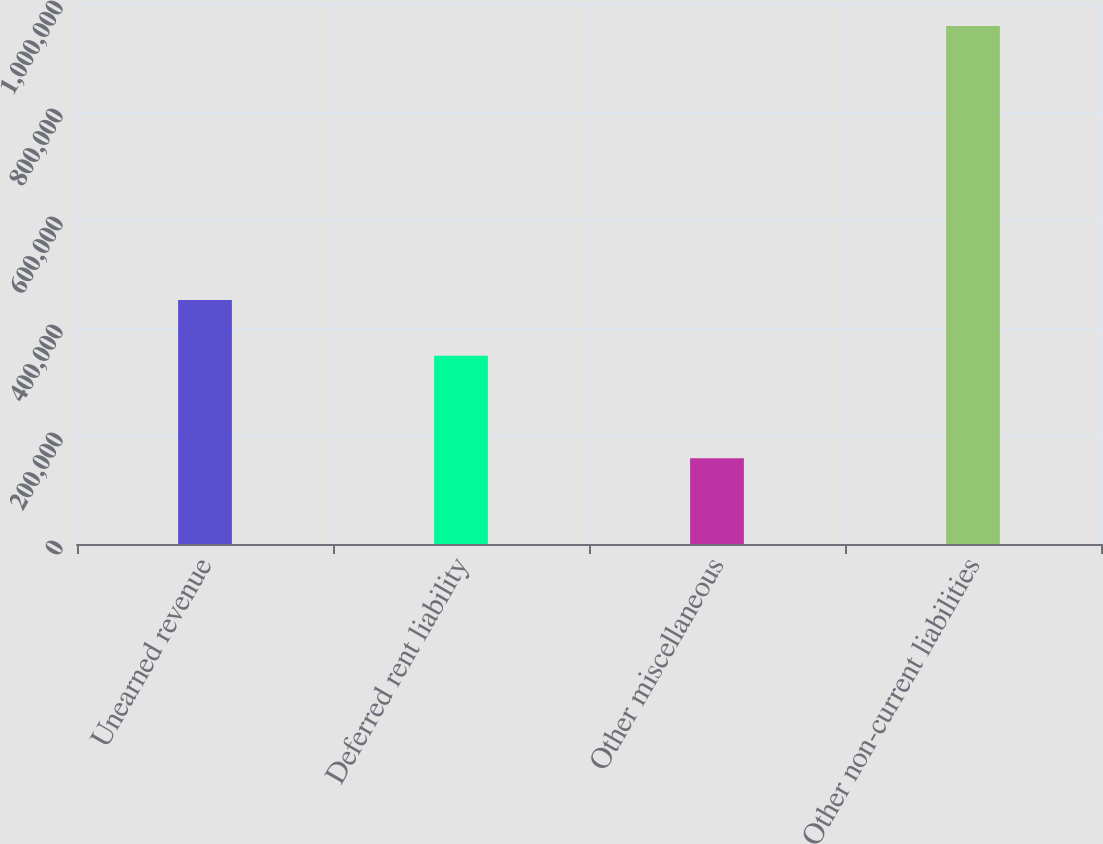Convert chart. <chart><loc_0><loc_0><loc_500><loc_500><bar_chart><fcel>Unearned revenue<fcel>Deferred rent liability<fcel>Other miscellaneous<fcel>Other non-current liabilities<nl><fcel>451844<fcel>348532<fcel>158973<fcel>959349<nl></chart> 